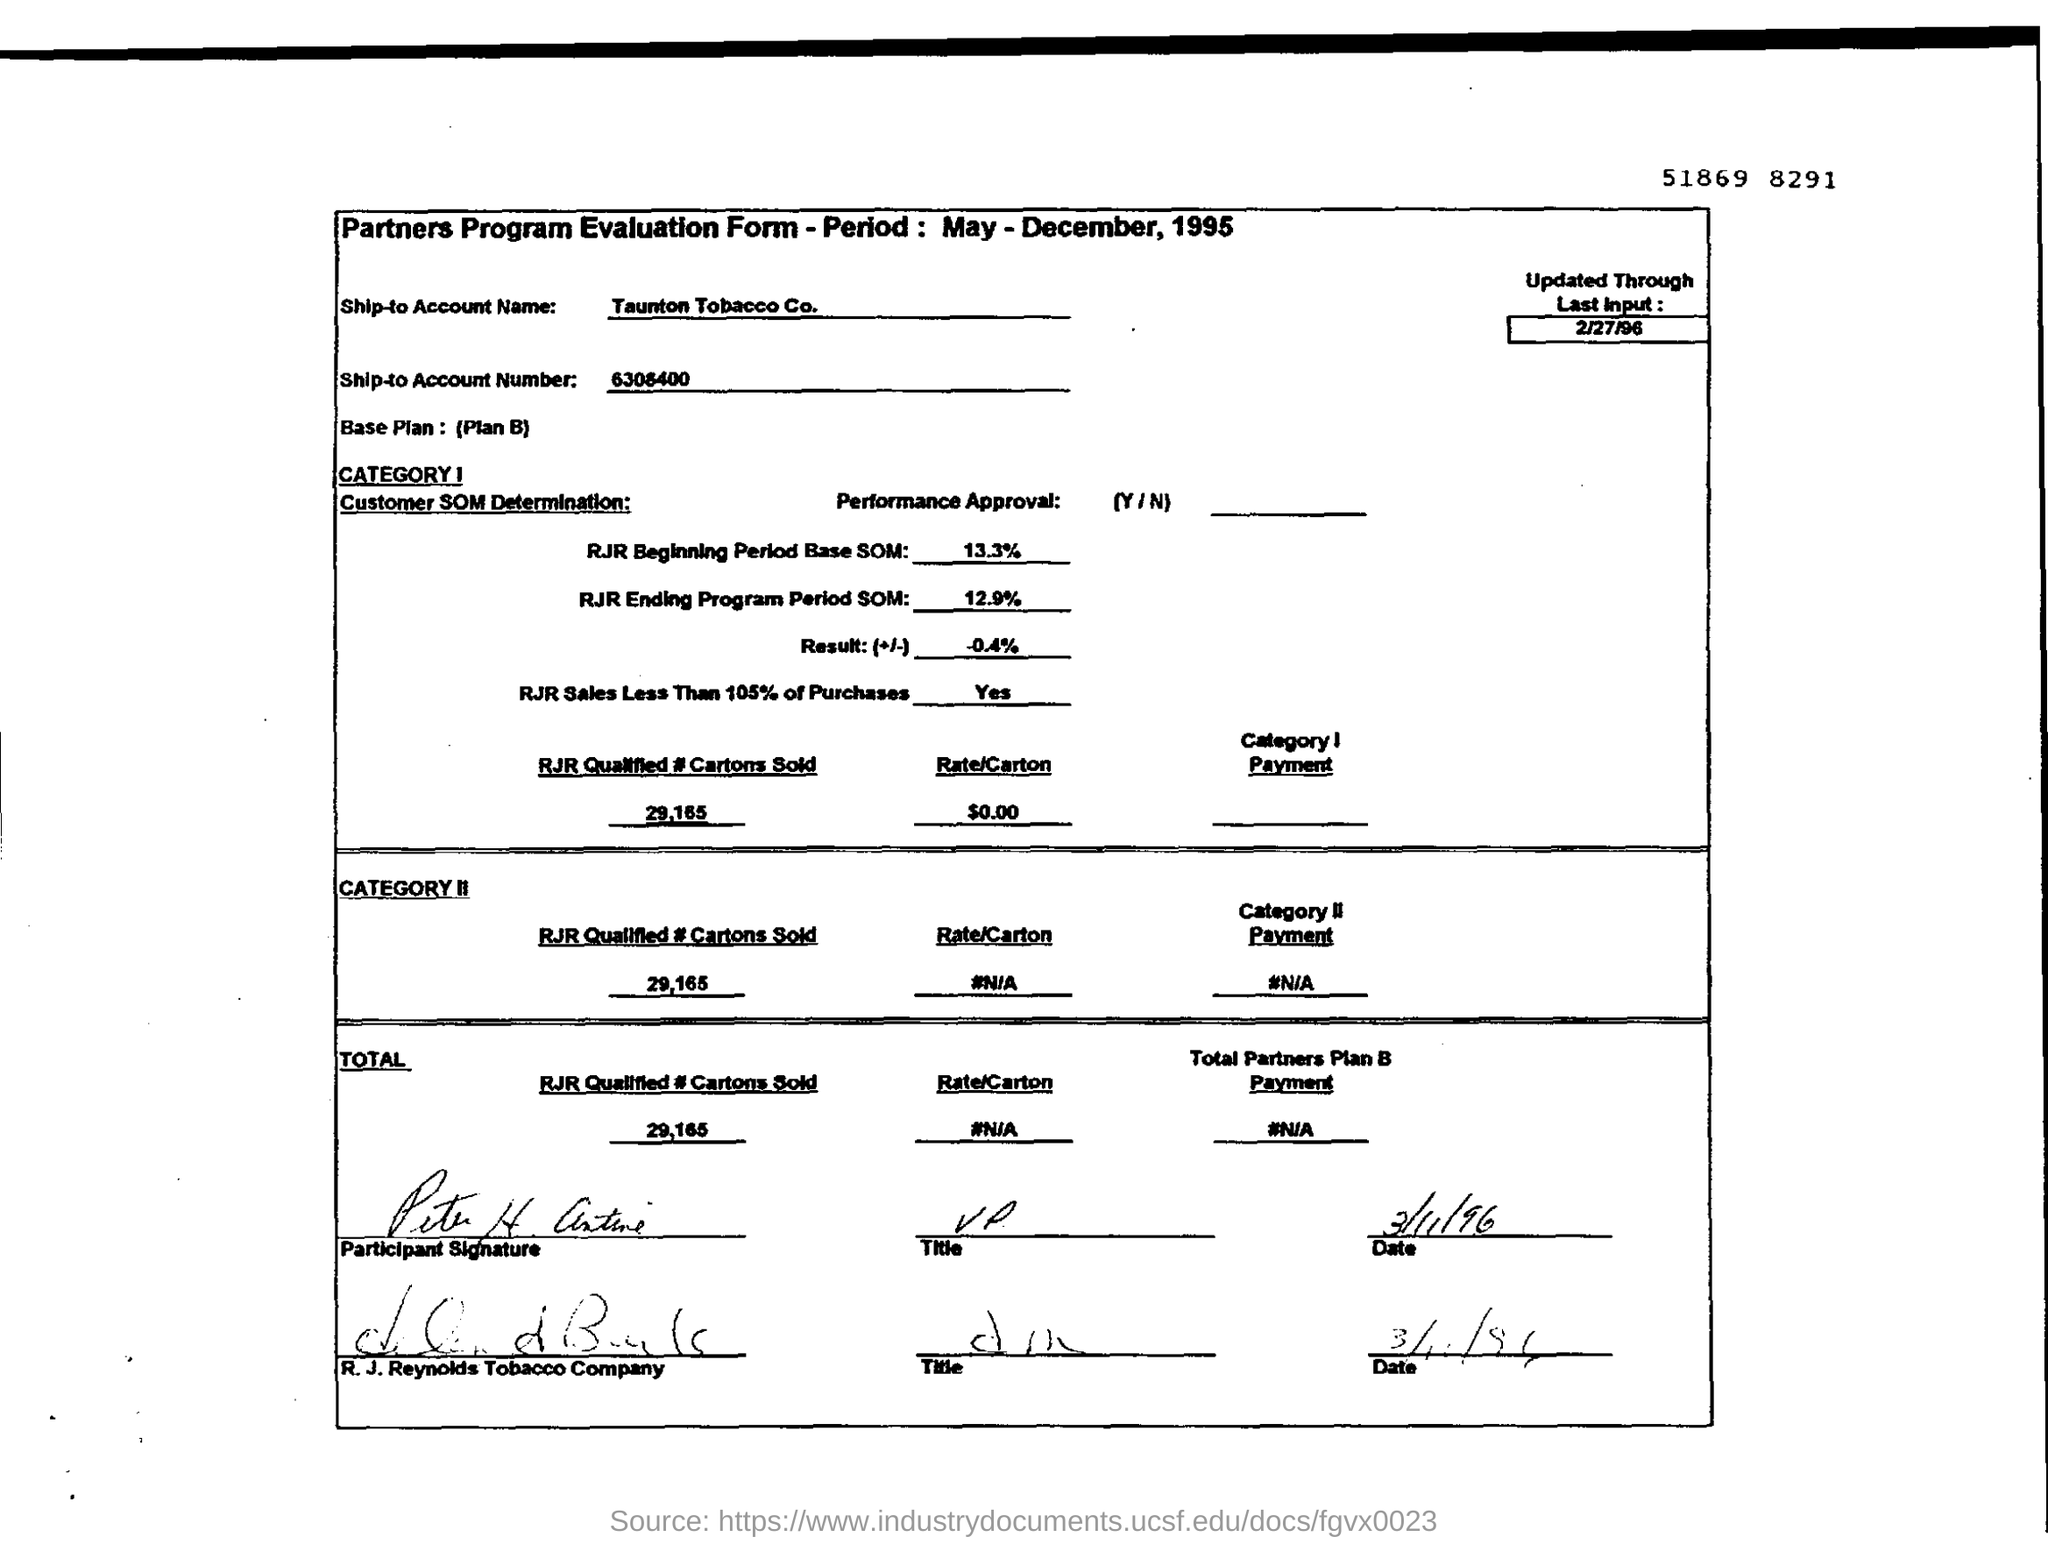Indicate a few pertinent items in this graphic. RJR's Beginning Period Base SOM is 13.3%. 